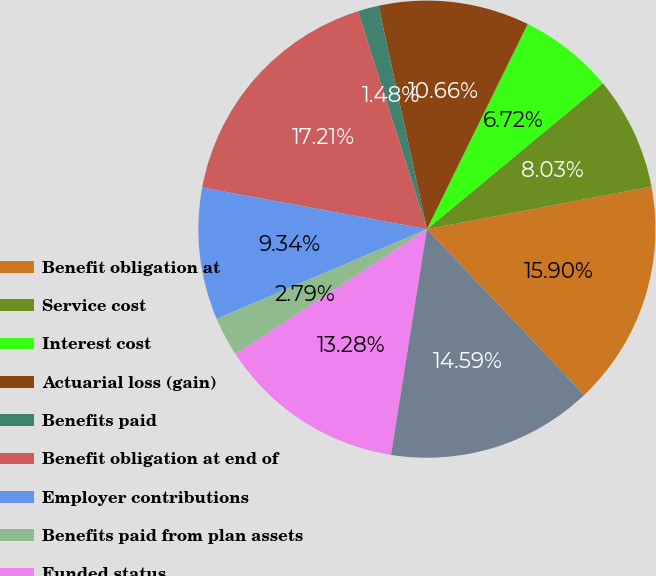<chart> <loc_0><loc_0><loc_500><loc_500><pie_chart><fcel>Benefit obligation at<fcel>Service cost<fcel>Interest cost<fcel>Actuarial loss (gain)<fcel>Benefits paid<fcel>Benefit obligation at end of<fcel>Employer contributions<fcel>Benefits paid from plan assets<fcel>Funded status<fcel>Unrecognized net actuarial<nl><fcel>15.9%<fcel>8.03%<fcel>6.72%<fcel>10.66%<fcel>1.48%<fcel>17.21%<fcel>9.34%<fcel>2.79%<fcel>13.28%<fcel>14.59%<nl></chart> 